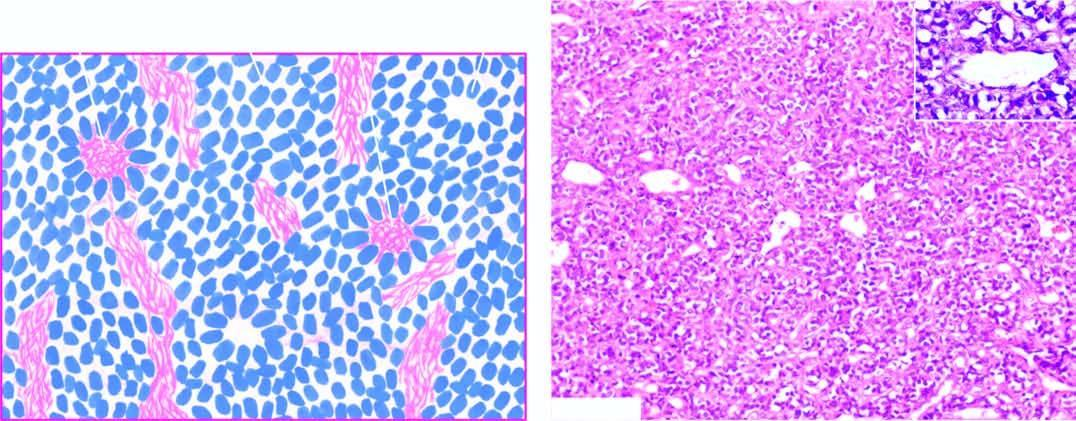what shows small, round to oval cells forming irregular sheets separated by fibrovascular stroma?
Answer the question using a single word or phrase. Neuroblastoma 